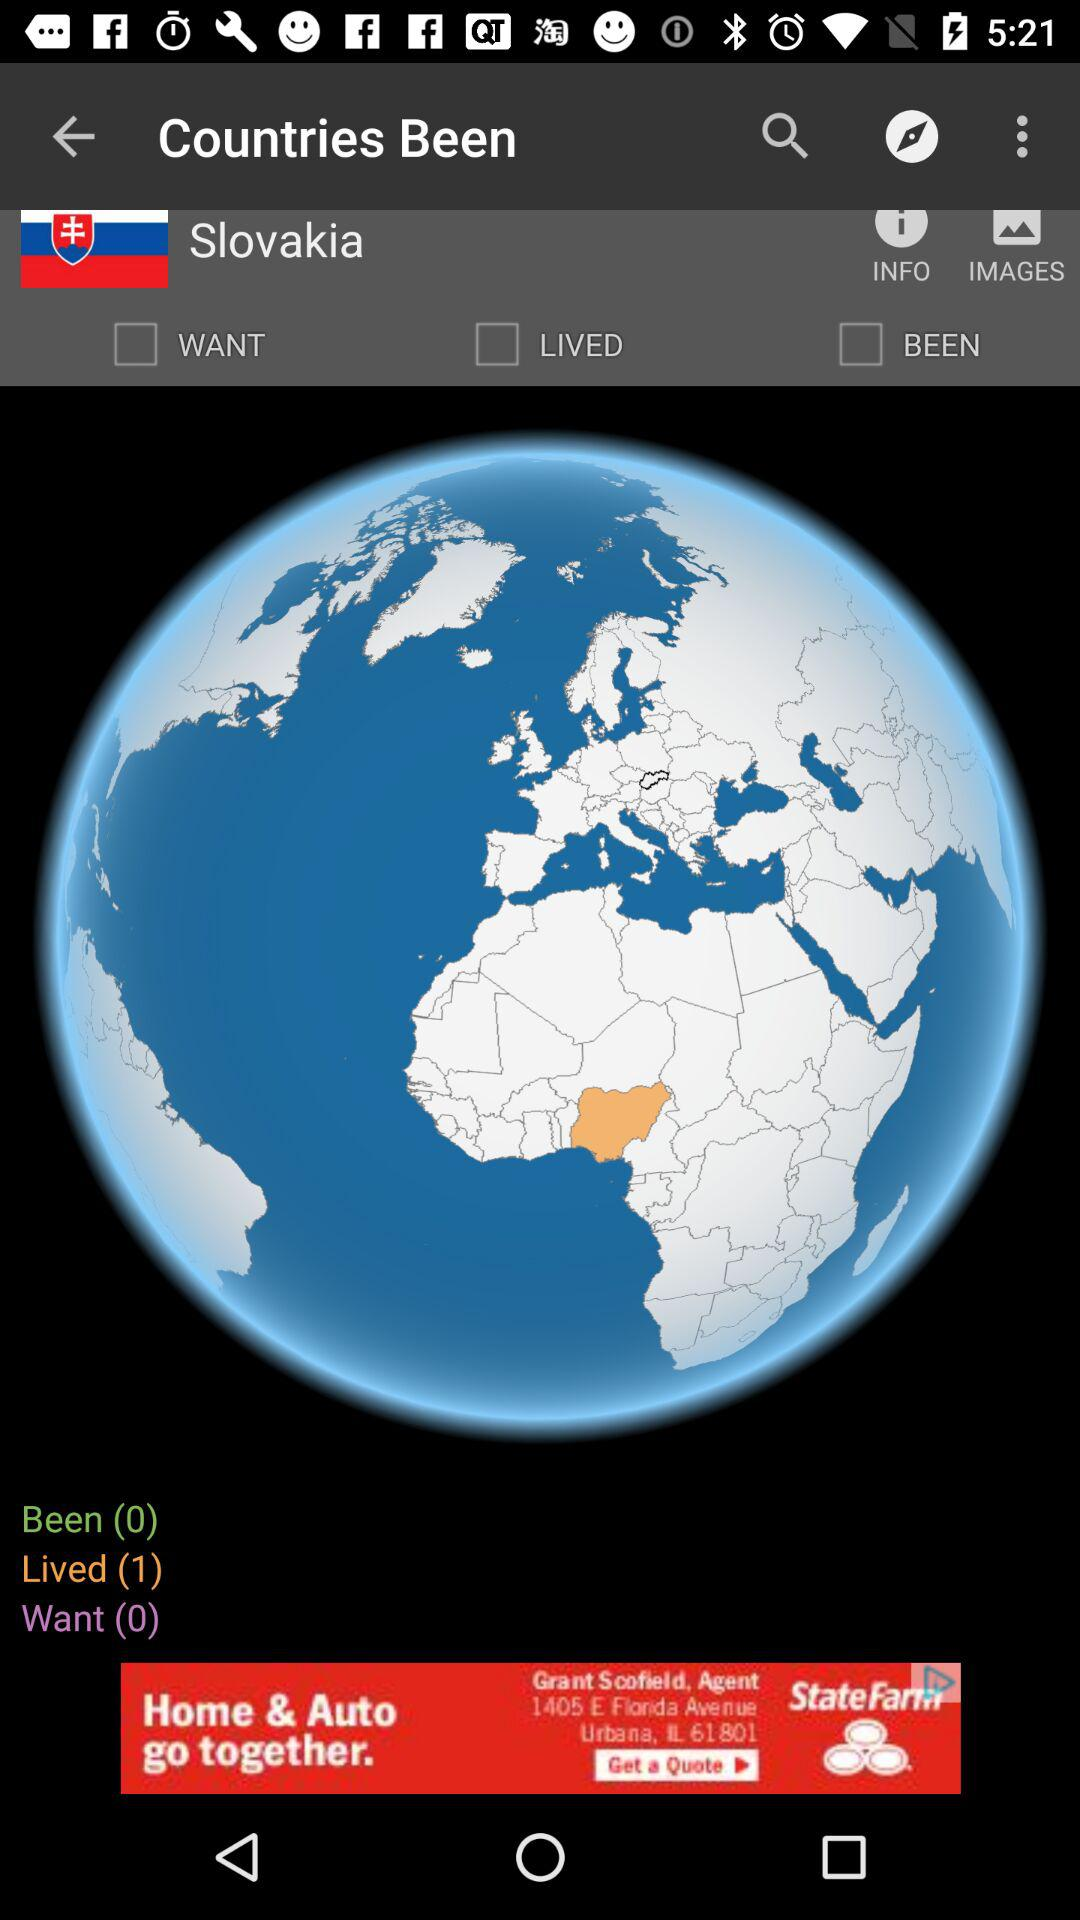How many countries have I lived in?
Answer the question using a single word or phrase. 1 